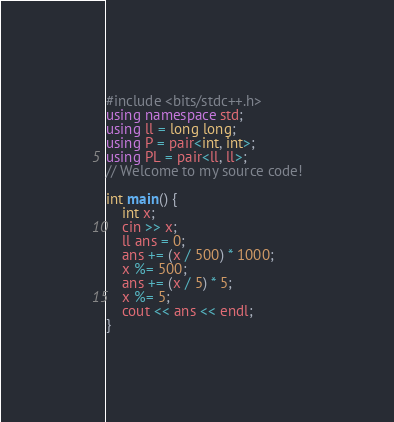Convert code to text. <code><loc_0><loc_0><loc_500><loc_500><_C++_>#include <bits/stdc++.h>
using namespace std;
using ll = long long;
using P = pair<int, int>;
using PL = pair<ll, ll>;
// Welcome to my source code!

int main() {
    int x;
    cin >> x;
    ll ans = 0;
    ans += (x / 500) * 1000;
    x %= 500;
    ans += (x / 5) * 5;
    x %= 5;
    cout << ans << endl;
}</code> 